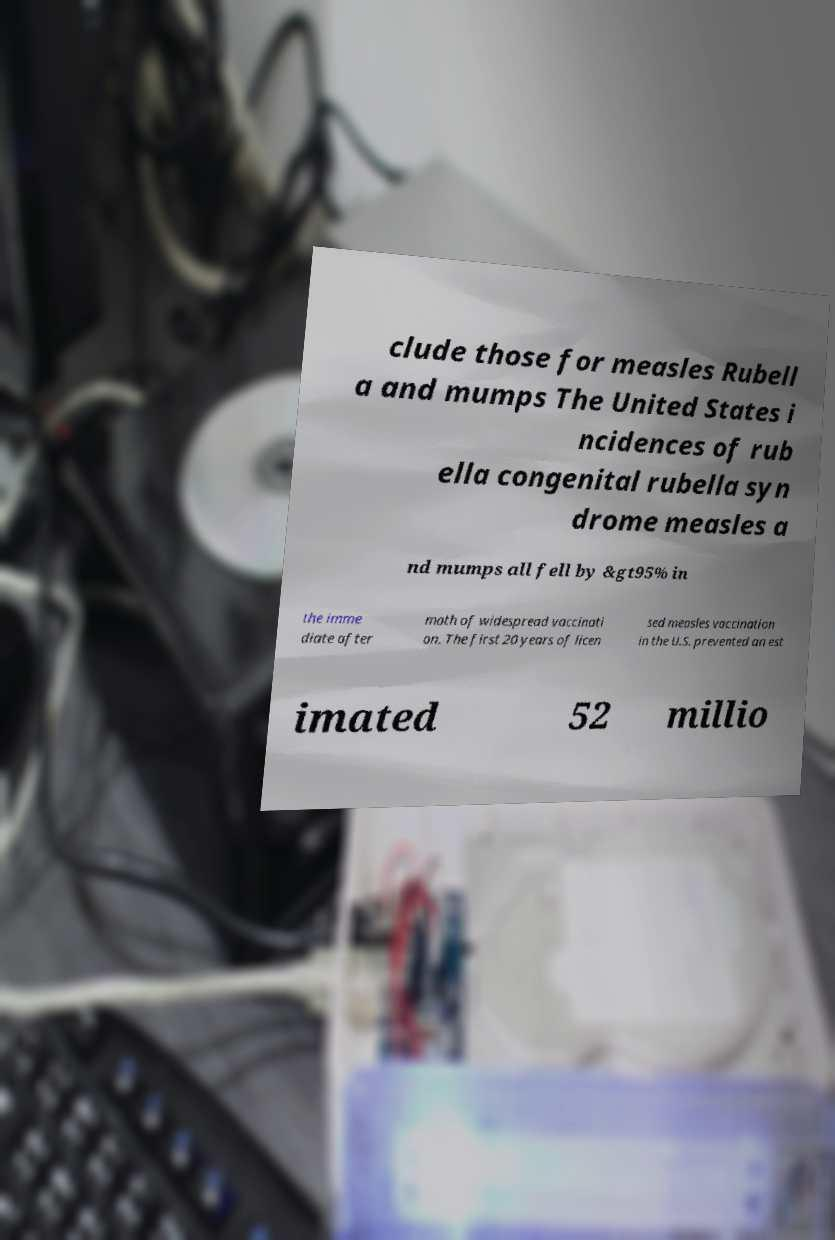Could you assist in decoding the text presented in this image and type it out clearly? clude those for measles Rubell a and mumps The United States i ncidences of rub ella congenital rubella syn drome measles a nd mumps all fell by &gt95% in the imme diate after math of widespread vaccinati on. The first 20 years of licen sed measles vaccination in the U.S. prevented an est imated 52 millio 